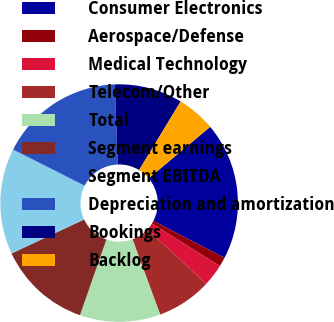Convert chart to OTSL. <chart><loc_0><loc_0><loc_500><loc_500><pie_chart><fcel>Consumer Electronics<fcel>Aerospace/Defense<fcel>Medical Technology<fcel>Telecom/Other<fcel>Total<fcel>Segment earnings<fcel>Segment EBITDA<fcel>Depreciation and amortization<fcel>Bookings<fcel>Backlog<nl><fcel>18.71%<fcel>1.27%<fcel>3.0%<fcel>7.5%<fcel>10.96%<fcel>12.68%<fcel>14.41%<fcel>16.99%<fcel>9.23%<fcel>5.24%<nl></chart> 